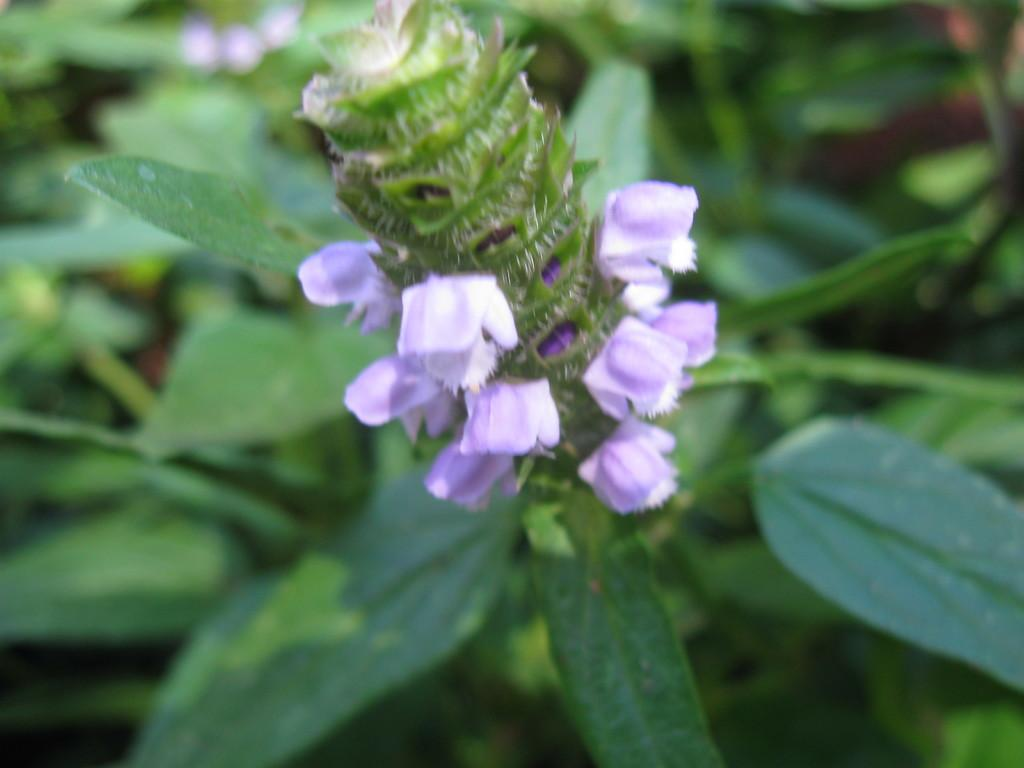What type of living organisms can be seen in the image? Plants and flowers are visible in the image. Can you describe the specific types of plants in the image? The image contains plants with flowers. What type of vegetable is being used as a comb in the image? There is no vegetable being used as a comb in the image. 